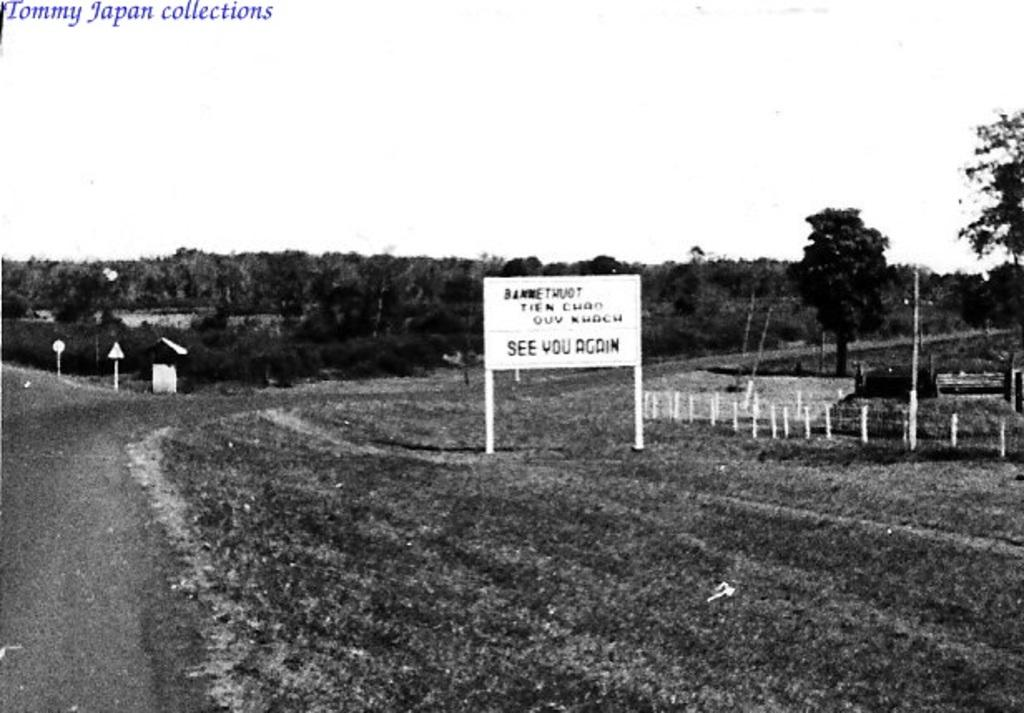What is the color scheme of the image? The image is black and white. What type of natural elements can be seen in the image? There are trees in the image. What man-made structures are present in the image? There are boards and poles in the image. Are there any objects visible in the image? Yes, there are some objects in the image. What is written at the top of the image? There is text at the top of the image. What is visible at the bottom of the image? There is ground visible at the bottom of the image. What type of yam is being used to make music in the image? There is no yam present in the image, and therefore no such activity can be observed. How many bells are hanging from the trees in the image? There are no bells present in the image; only trees, boards, poles, objects, text, and ground are visible. 